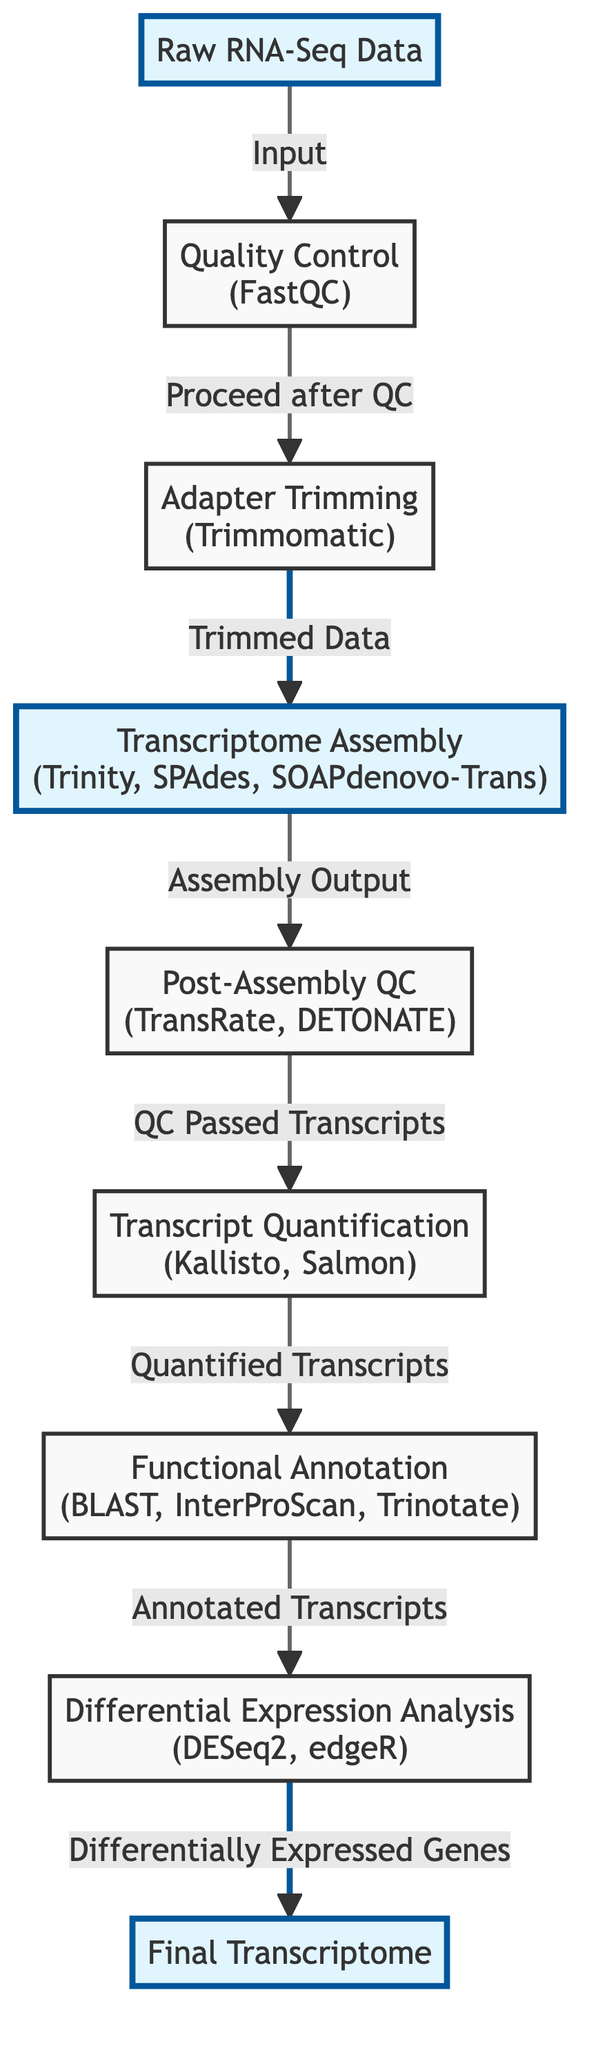What is the first step in the workflow? The first step in the workflow is labeled "Raw RNA-Seq Data," which indicates that this is the initial input required for the entire process.
Answer: Raw RNA-Seq Data How many software tools are involved in the assembly step? The assembly step is indicated to include three software options: Trinity, SPAdes, and SOAPdenovo-Trans. This counts as three distinct tools.
Answer: 3 Which step follows Quality Control? After the Quality Control step, as indicated by the arrow leading out from it, the next step is Adapter Trimming.
Answer: Adapter Trimming What is the output of the Transcriptome Assembly step? The output of the Transcriptome Assembly step is designated as "Assembly Output," which directs to the next step in the workflow.
Answer: Assembly Output What two processes follow the Post-Assembly QC step? After the Post-Assembly QC step, the workflow proceeds to two processes: Transcript Quantification and then Functional Annotation, based on the directional arrows.
Answer: Transcript Quantification, Functional Annotation Which software is used for Differential Expression Analysis? The software indicated for Differential Expression Analysis in the diagram is DESeq2, alongside edgeR as an alternative.
Answer: DESeq2, edgeR What is the final output of the workflow? The final output of the workflow is labeled as "Final Transcriptome," which denotes the completed product after all prior steps have been executed.
Answer: Final Transcriptome How many total nodes are in this workflow diagram? There are eight distinct nodes present in the workflow as visualized, each representing a different step or process.
Answer: 8 What happens to the output of the Assembly step if it does not pass the Post-Assembly QC? If the output of the Assembly step does not pass the Post-Assembly QC, it does not continue to the subsequent processes of Transcript Quantification and Functional Annotation. It breaks the flow.
Answer: It does not continue 